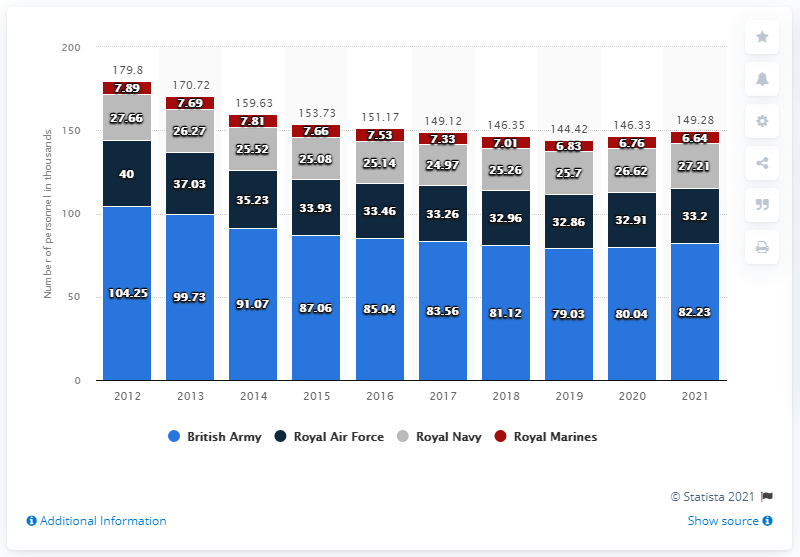Point out several critical features in this image. The number of British Army was the highest in 2012. In 2019, the number of British Army and Royal Marines was the least. 